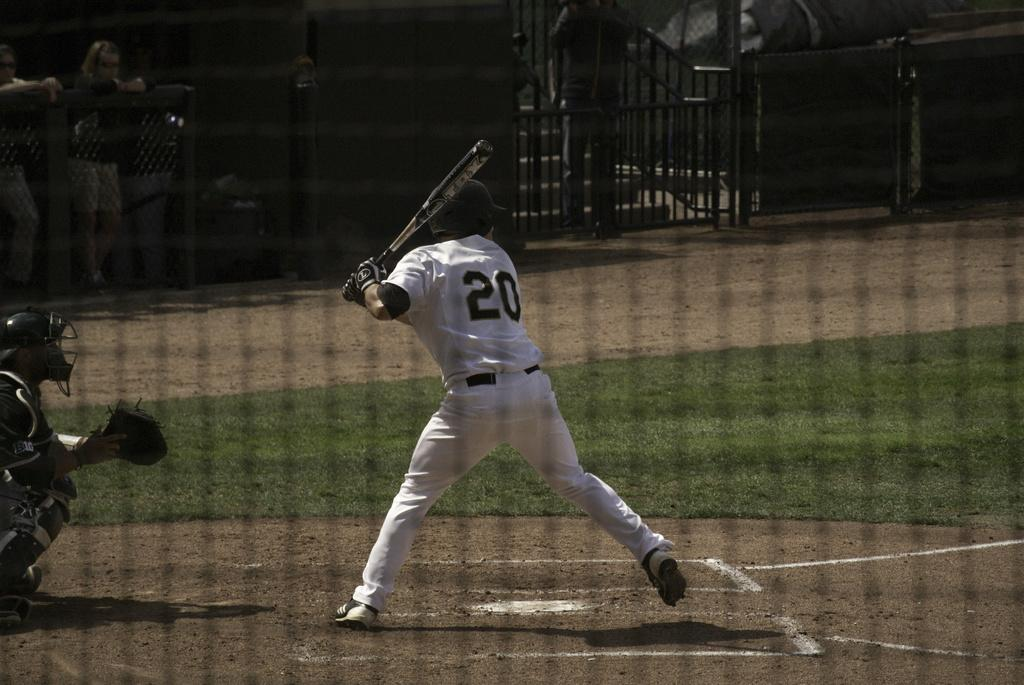<image>
Render a clear and concise summary of the photo. A baseball player with number 20 on his back is ready to swing his bat 